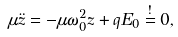Convert formula to latex. <formula><loc_0><loc_0><loc_500><loc_500>\mu \ddot { z } = - \mu \omega _ { 0 } ^ { 2 } z + q E _ { 0 } \stackrel { ! } { = } 0 ,</formula> 